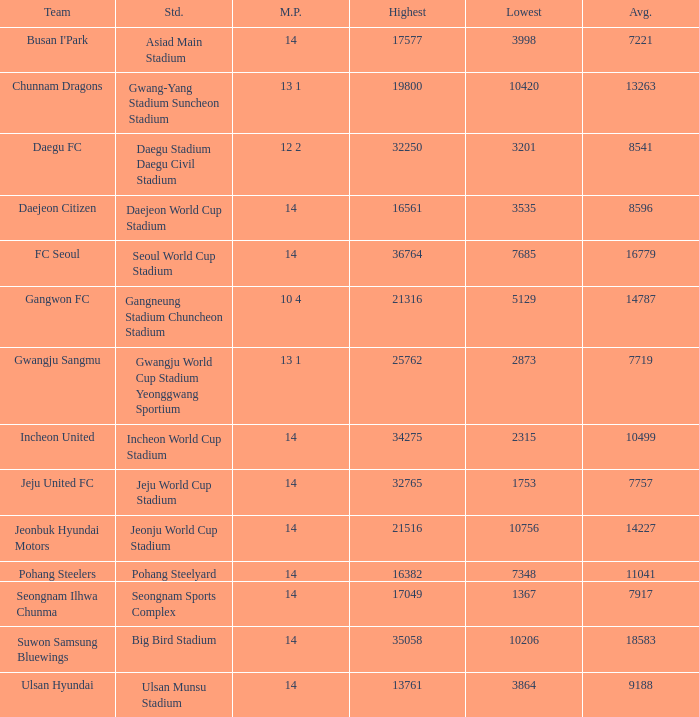What is the lowest when pohang steelyard is the stadium? 7348.0. 